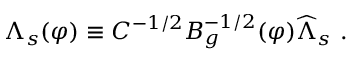<formula> <loc_0><loc_0><loc_500><loc_500>\Lambda _ { s } ( \varphi ) \equiv C ^ { - 1 / 2 } B _ { g } ^ { - 1 / 2 } ( \varphi ) \widehat { \Lambda } _ { s } \ .</formula> 